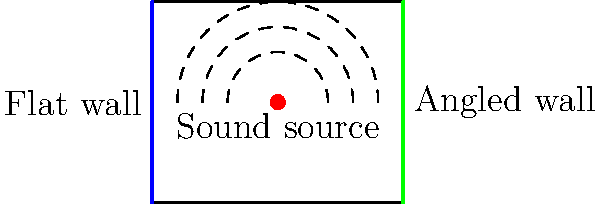In the studio layout shown above, which wall design would be more effective for reducing sound reflections and improving acoustic quality? To answer this question, we need to consider the principles of sound reflection and absorption in studio environments:

1. Sound waves behave similarly to light waves when they encounter surfaces. They can be reflected, absorbed, or diffused.

2. Flat surfaces tend to reflect sound waves at the same angle as the incident wave, creating strong echoes and potential standing waves.

3. Angled or irregular surfaces scatter sound waves in different directions, which helps to diffuse the sound and reduce strong reflections.

4. In professional recording studios, reducing unwanted reflections is crucial for achieving clear and accurate sound reproduction.

5. The flat wall in the diagram will reflect sound waves directly back into the room, potentially causing interference patterns and acoustic issues.

6. The angled wall, on the other hand, will scatter the incident sound waves in different directions, helping to diffuse the sound and reduce strong reflections.

7. Diffusion of sound waves contributes to a more even sound field in the room, which is desirable for accurate monitoring and recording.

8. While both walls may have some sound-absorbing properties depending on their material, the angled design provides an additional benefit of sound diffusion.

Therefore, the angled wall design would be more effective for reducing sound reflections and improving the overall acoustic quality of the studio space.
Answer: Angled wall 